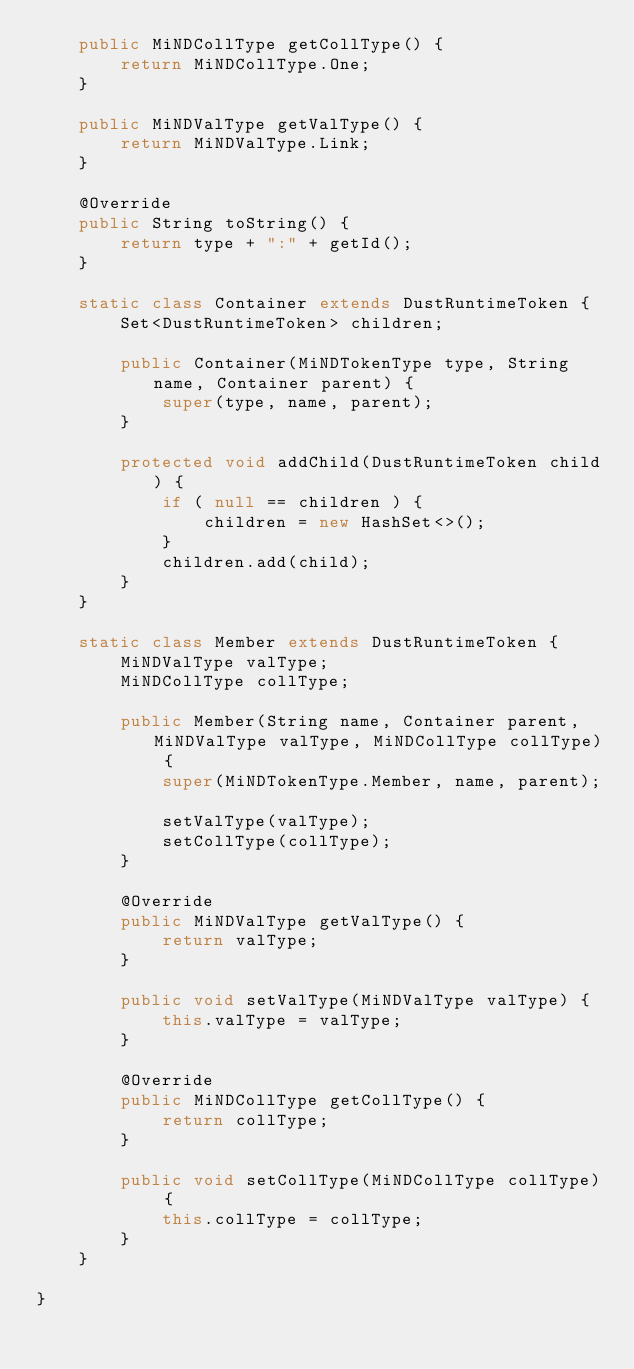<code> <loc_0><loc_0><loc_500><loc_500><_Java_>	public MiNDCollType getCollType() {
		return MiNDCollType.One;
	}

	public MiNDValType getValType() {
		return MiNDValType.Link;
	}

	@Override
	public String toString() {
		return type + ":" + getId();
	}

	static class Container extends DustRuntimeToken {
		Set<DustRuntimeToken> children;

		public Container(MiNDTokenType type, String name, Container parent) {
			super(type, name, parent);
		}

		protected void addChild(DustRuntimeToken child) {
			if ( null == children ) {
				children = new HashSet<>();
			}
			children.add(child);
		}
	}

	static class Member extends DustRuntimeToken {
		MiNDValType valType;
		MiNDCollType collType;

		public Member(String name, Container parent, MiNDValType valType, MiNDCollType collType) {
			super(MiNDTokenType.Member, name, parent);

			setValType(valType);
			setCollType(collType);
		}

		@Override
		public MiNDValType getValType() {
			return valType;
		}

		public void setValType(MiNDValType valType) {
			this.valType = valType;
		}

		@Override
		public MiNDCollType getCollType() {
			return collType;
		}

		public void setCollType(MiNDCollType collType) {
			this.collType = collType;
		}
	}

}</code> 